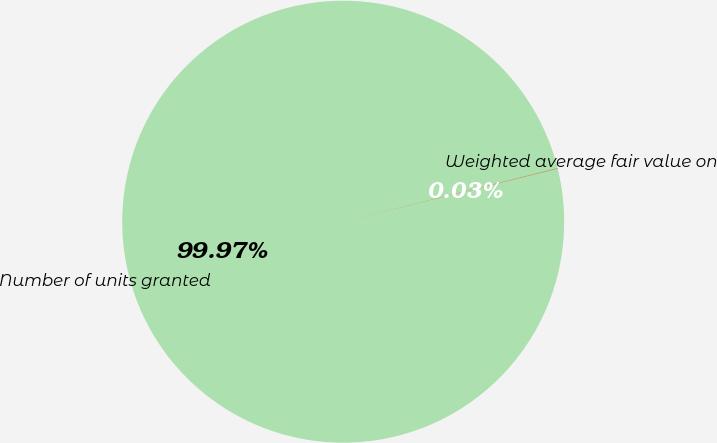Convert chart to OTSL. <chart><loc_0><loc_0><loc_500><loc_500><pie_chart><fcel>Number of units granted<fcel>Weighted average fair value on<nl><fcel>99.97%<fcel>0.03%<nl></chart> 